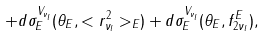<formula> <loc_0><loc_0><loc_500><loc_500>+ d \sigma _ { E } ^ { V _ { \nu _ { l } } } ( \theta _ { E } , < r ^ { 2 } _ { \nu _ { l } } > _ { E } ) + d \sigma _ { E } ^ { V _ { \nu _ { l } } } ( \theta _ { E } , f _ { 2 \nu _ { l } } ^ { E } ) ,</formula> 